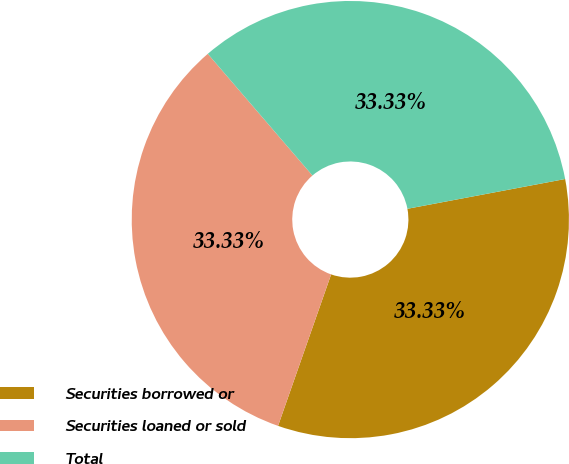Convert chart. <chart><loc_0><loc_0><loc_500><loc_500><pie_chart><fcel>Securities borrowed or<fcel>Securities loaned or sold<fcel>Total<nl><fcel>33.33%<fcel>33.33%<fcel>33.33%<nl></chart> 